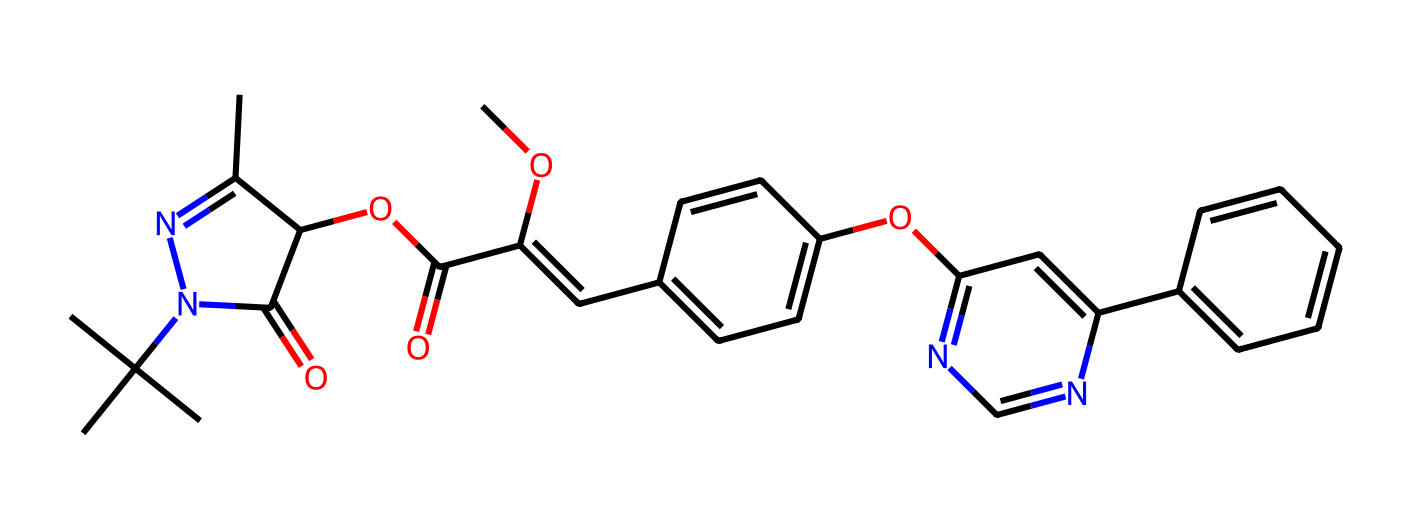What is the primary functional group in azoxystrobin? The SMILES structure reveals the presence of a carbonyl group (C=O) and an ester group (C(=O)O), which are indicative of the functional groups present in azoxystrobin. The ester group is particularly significant as it is commonly associated with fungicides.
Answer: ester How many nitrogen atoms are present in azoxystrobin? By analyzing the SMILES representation, we can identify the nitrogen atoms in the chemical structure. There are two distinct occurrences of nitrogen (N) present, located within cyclic structures.
Answer: two What is the molecular weight of azoxystrobin? To determine the molecular weight, we must first derive the molecular formula from the SMILES representation and then calculate the weight using atomic masses. The calculated molecular weight is approximately 404.43 g/mol.
Answer: 404.43 Which part of azoxystrobin contributes to its fungicidal properties? In azoxystrobin, the presence of the heterocyclic nitrogen-containing ring contributes to its activity as a fungicide. This ring impacts the interaction with target enzymes in fungi, making it crucial for its fungicidal function.
Answer: heterocyclic ring How many carbon atoms are present in azoxystrobin? By examining the SMILES notation, we can count the total number of carbon atoms in the chemical structure. There are a total of 23 carbon (C) atoms represented in the molecule.
Answer: 23 